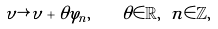Convert formula to latex. <formula><loc_0><loc_0><loc_500><loc_500>\upsilon \rightarrow \upsilon + \theta \varphi _ { n } , \text {\quad } \theta \in \mathbb { R } , \text { } n \in \mathbb { Z } ,</formula> 